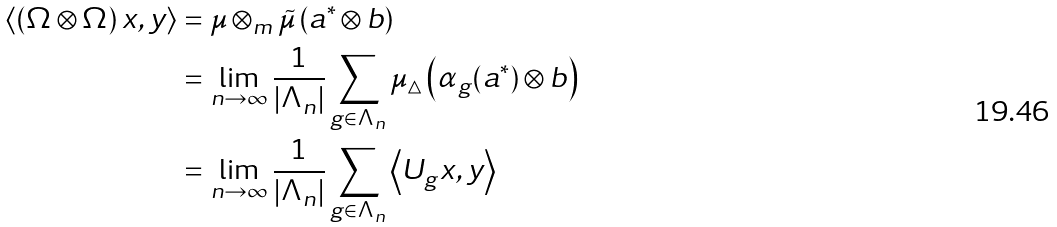Convert formula to latex. <formula><loc_0><loc_0><loc_500><loc_500>\left \langle \left ( \Omega \otimes \Omega \right ) x , y \right \rangle & = \mu \otimes _ { m } \tilde { \mu } \left ( a ^ { \ast } \otimes b \right ) \\ & = \lim _ { n \rightarrow \infty } \frac { 1 } { \left | \Lambda _ { n } \right | } \sum _ { g \in \Lambda _ { n } } \mu _ { \bigtriangleup } \left ( \alpha _ { g } ( a ^ { \ast } ) \otimes b \right ) \\ & = \lim _ { n \rightarrow \infty } \frac { 1 } { \left | \Lambda _ { n } \right | } \sum _ { g \in \Lambda _ { n } } \left \langle U _ { g } x , y \right \rangle</formula> 